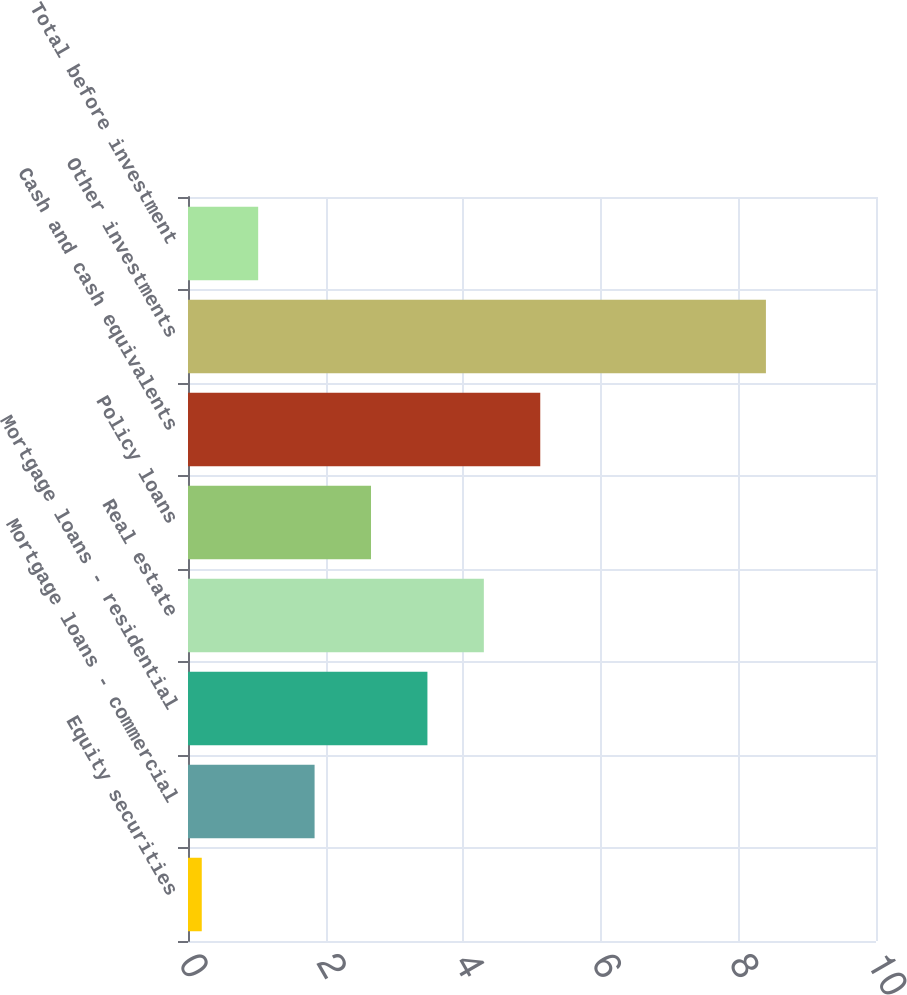Convert chart. <chart><loc_0><loc_0><loc_500><loc_500><bar_chart><fcel>Equity securities<fcel>Mortgage loans - commercial<fcel>Mortgage loans - residential<fcel>Real estate<fcel>Policy loans<fcel>Cash and cash equivalents<fcel>Other investments<fcel>Total before investment<nl><fcel>0.2<fcel>1.84<fcel>3.48<fcel>4.3<fcel>2.66<fcel>5.12<fcel>8.4<fcel>1.02<nl></chart> 